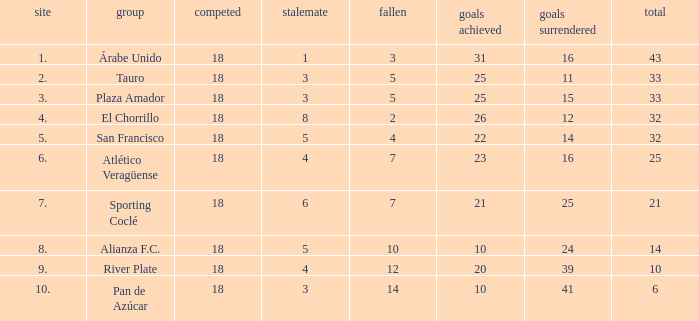Can you parse all the data within this table? {'header': ['site', 'group', 'competed', 'stalemate', 'fallen', 'goals achieved', 'goals surrendered', 'total'], 'rows': [['1.', 'Árabe Unido', '18', '1', '3', '31', '16', '43'], ['2.', 'Tauro', '18', '3', '5', '25', '11', '33'], ['3.', 'Plaza Amador', '18', '3', '5', '25', '15', '33'], ['4.', 'El Chorrillo', '18', '8', '2', '26', '12', '32'], ['5.', 'San Francisco', '18', '5', '4', '22', '14', '32'], ['6.', 'Atlético Veragüense', '18', '4', '7', '23', '16', '25'], ['7.', 'Sporting Coclé', '18', '6', '7', '21', '25', '21'], ['8.', 'Alianza F.C.', '18', '5', '10', '10', '24', '14'], ['9.', 'River Plate', '18', '4', '12', '20', '39', '10'], ['10.', 'Pan de Azúcar', '18', '3', '14', '10', '41', '6']]} How many goals were conceded by the team with more than 21 points more than 5 draws and less than 18 games played? None. 